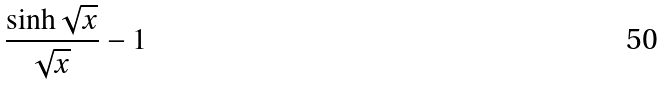<formula> <loc_0><loc_0><loc_500><loc_500>\frac { \sinh \sqrt { x } } { \sqrt { x } } - 1</formula> 